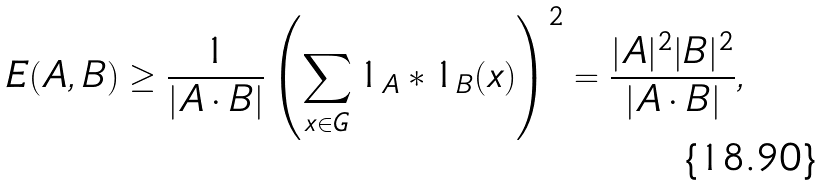Convert formula to latex. <formula><loc_0><loc_0><loc_500><loc_500>E ( A , B ) \geq \frac { 1 } { | A \cdot B | } \left ( \sum _ { x \in G } 1 _ { A } * 1 _ { B } ( x ) \right ) ^ { 2 } = \frac { | A | ^ { 2 } | B | ^ { 2 } } { | A \cdot B | } ,</formula> 